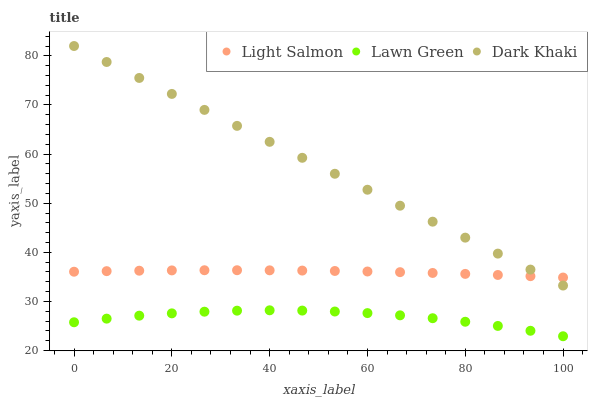Does Lawn Green have the minimum area under the curve?
Answer yes or no. Yes. Does Dark Khaki have the maximum area under the curve?
Answer yes or no. Yes. Does Light Salmon have the minimum area under the curve?
Answer yes or no. No. Does Light Salmon have the maximum area under the curve?
Answer yes or no. No. Is Dark Khaki the smoothest?
Answer yes or no. Yes. Is Lawn Green the roughest?
Answer yes or no. Yes. Is Light Salmon the smoothest?
Answer yes or no. No. Is Light Salmon the roughest?
Answer yes or no. No. Does Lawn Green have the lowest value?
Answer yes or no. Yes. Does Light Salmon have the lowest value?
Answer yes or no. No. Does Dark Khaki have the highest value?
Answer yes or no. Yes. Does Light Salmon have the highest value?
Answer yes or no. No. Is Lawn Green less than Light Salmon?
Answer yes or no. Yes. Is Light Salmon greater than Lawn Green?
Answer yes or no. Yes. Does Dark Khaki intersect Light Salmon?
Answer yes or no. Yes. Is Dark Khaki less than Light Salmon?
Answer yes or no. No. Is Dark Khaki greater than Light Salmon?
Answer yes or no. No. Does Lawn Green intersect Light Salmon?
Answer yes or no. No. 